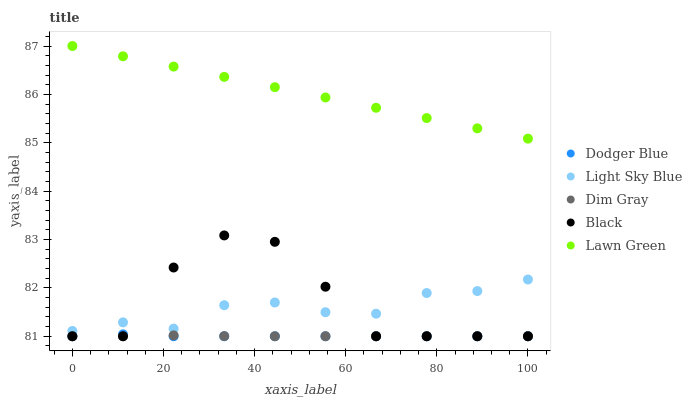Does Dim Gray have the minimum area under the curve?
Answer yes or no. Yes. Does Lawn Green have the maximum area under the curve?
Answer yes or no. Yes. Does Light Sky Blue have the minimum area under the curve?
Answer yes or no. No. Does Light Sky Blue have the maximum area under the curve?
Answer yes or no. No. Is Lawn Green the smoothest?
Answer yes or no. Yes. Is Black the roughest?
Answer yes or no. Yes. Is Dim Gray the smoothest?
Answer yes or no. No. Is Dim Gray the roughest?
Answer yes or no. No. Does Black have the lowest value?
Answer yes or no. Yes. Does Light Sky Blue have the lowest value?
Answer yes or no. No. Does Lawn Green have the highest value?
Answer yes or no. Yes. Does Light Sky Blue have the highest value?
Answer yes or no. No. Is Dodger Blue less than Lawn Green?
Answer yes or no. Yes. Is Light Sky Blue greater than Dim Gray?
Answer yes or no. Yes. Does Dodger Blue intersect Dim Gray?
Answer yes or no. Yes. Is Dodger Blue less than Dim Gray?
Answer yes or no. No. Is Dodger Blue greater than Dim Gray?
Answer yes or no. No. Does Dodger Blue intersect Lawn Green?
Answer yes or no. No. 